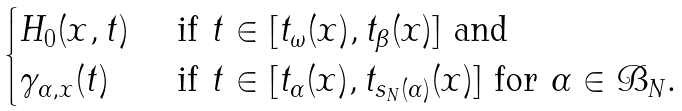<formula> <loc_0><loc_0><loc_500><loc_500>\begin{cases} H _ { 0 } ( x , t ) & \text { if } t \in [ t _ { \omega } ( x ) , t _ { \beta } ( x ) ] \text { and} \\ \gamma _ { \alpha , x } ( t ) & \text { if } t \in [ t _ { \alpha } ( x ) , t _ { s _ { N } ( \alpha ) } ( x ) ] \text { for $\alpha\in\mathcal{B}_{N}$.} \end{cases}</formula> 